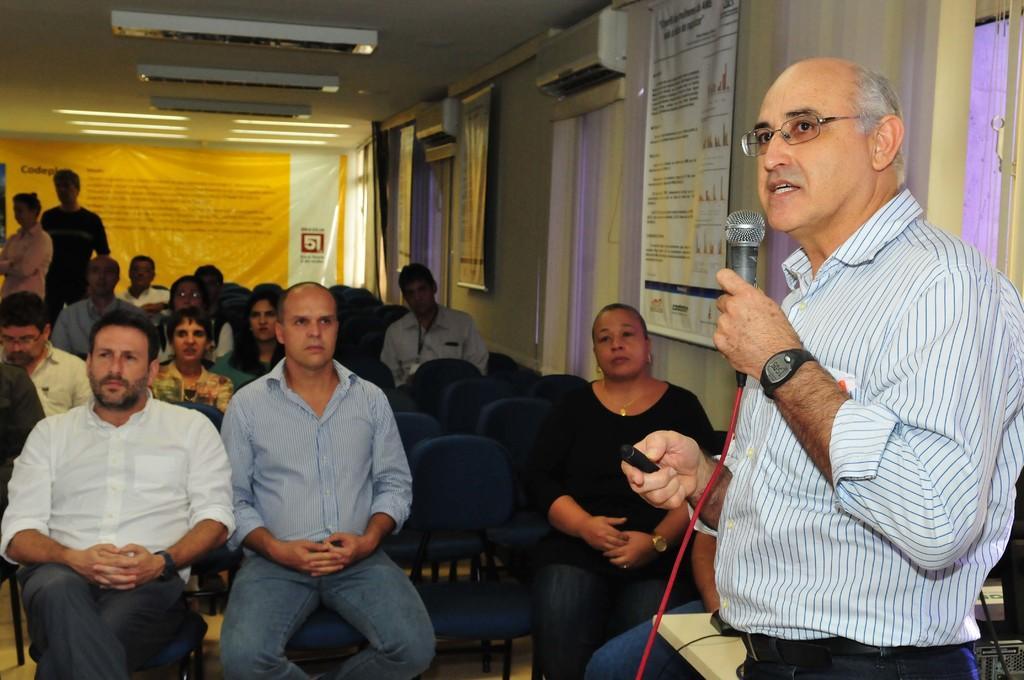In one or two sentences, can you explain what this image depicts? In this image I can see a person standing holding microphone and talking, background I can see few persons sitting on the chairs and I can see few persons standing. I can also see a banner in yellow and white color. 